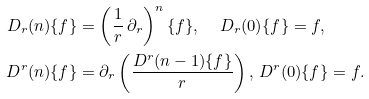<formula> <loc_0><loc_0><loc_500><loc_500>D _ { r } ( n ) \{ f \} & = \left ( \frac { 1 } { r } \, \partial _ { r } \right ) ^ { n } \{ f \} , \quad \, D _ { r } ( 0 ) \{ f \} = f , \\ D ^ { r } ( n ) \{ f \} & = \partial _ { r } \left ( \frac { D ^ { r } ( n - 1 ) \{ f \} } { r } \right ) , \, D ^ { r } ( 0 ) \{ f \} = f .</formula> 